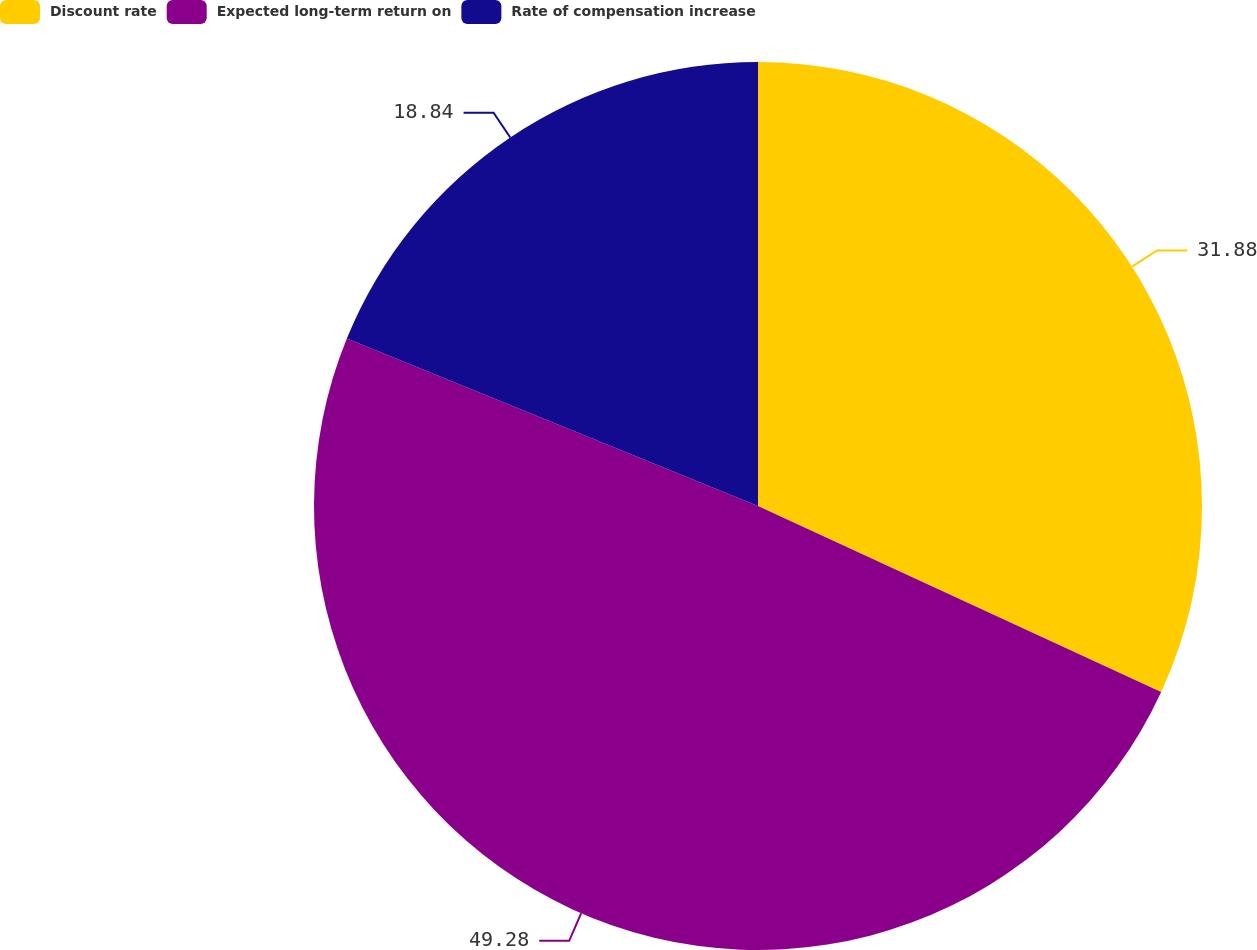Convert chart to OTSL. <chart><loc_0><loc_0><loc_500><loc_500><pie_chart><fcel>Discount rate<fcel>Expected long-term return on<fcel>Rate of compensation increase<nl><fcel>31.88%<fcel>49.28%<fcel>18.84%<nl></chart> 